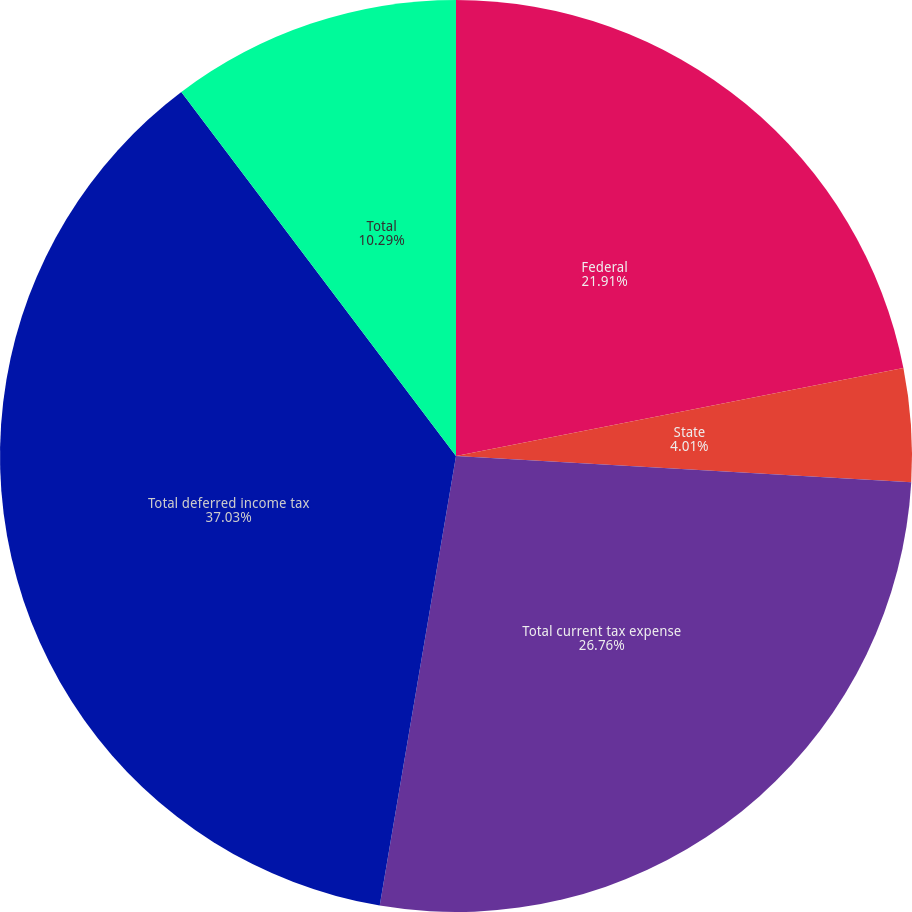Convert chart. <chart><loc_0><loc_0><loc_500><loc_500><pie_chart><fcel>Federal<fcel>State<fcel>Total current tax expense<fcel>Total deferred income tax<fcel>Total<nl><fcel>21.91%<fcel>4.01%<fcel>26.76%<fcel>37.04%<fcel>10.29%<nl></chart> 